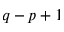<formula> <loc_0><loc_0><loc_500><loc_500>q - p + 1</formula> 